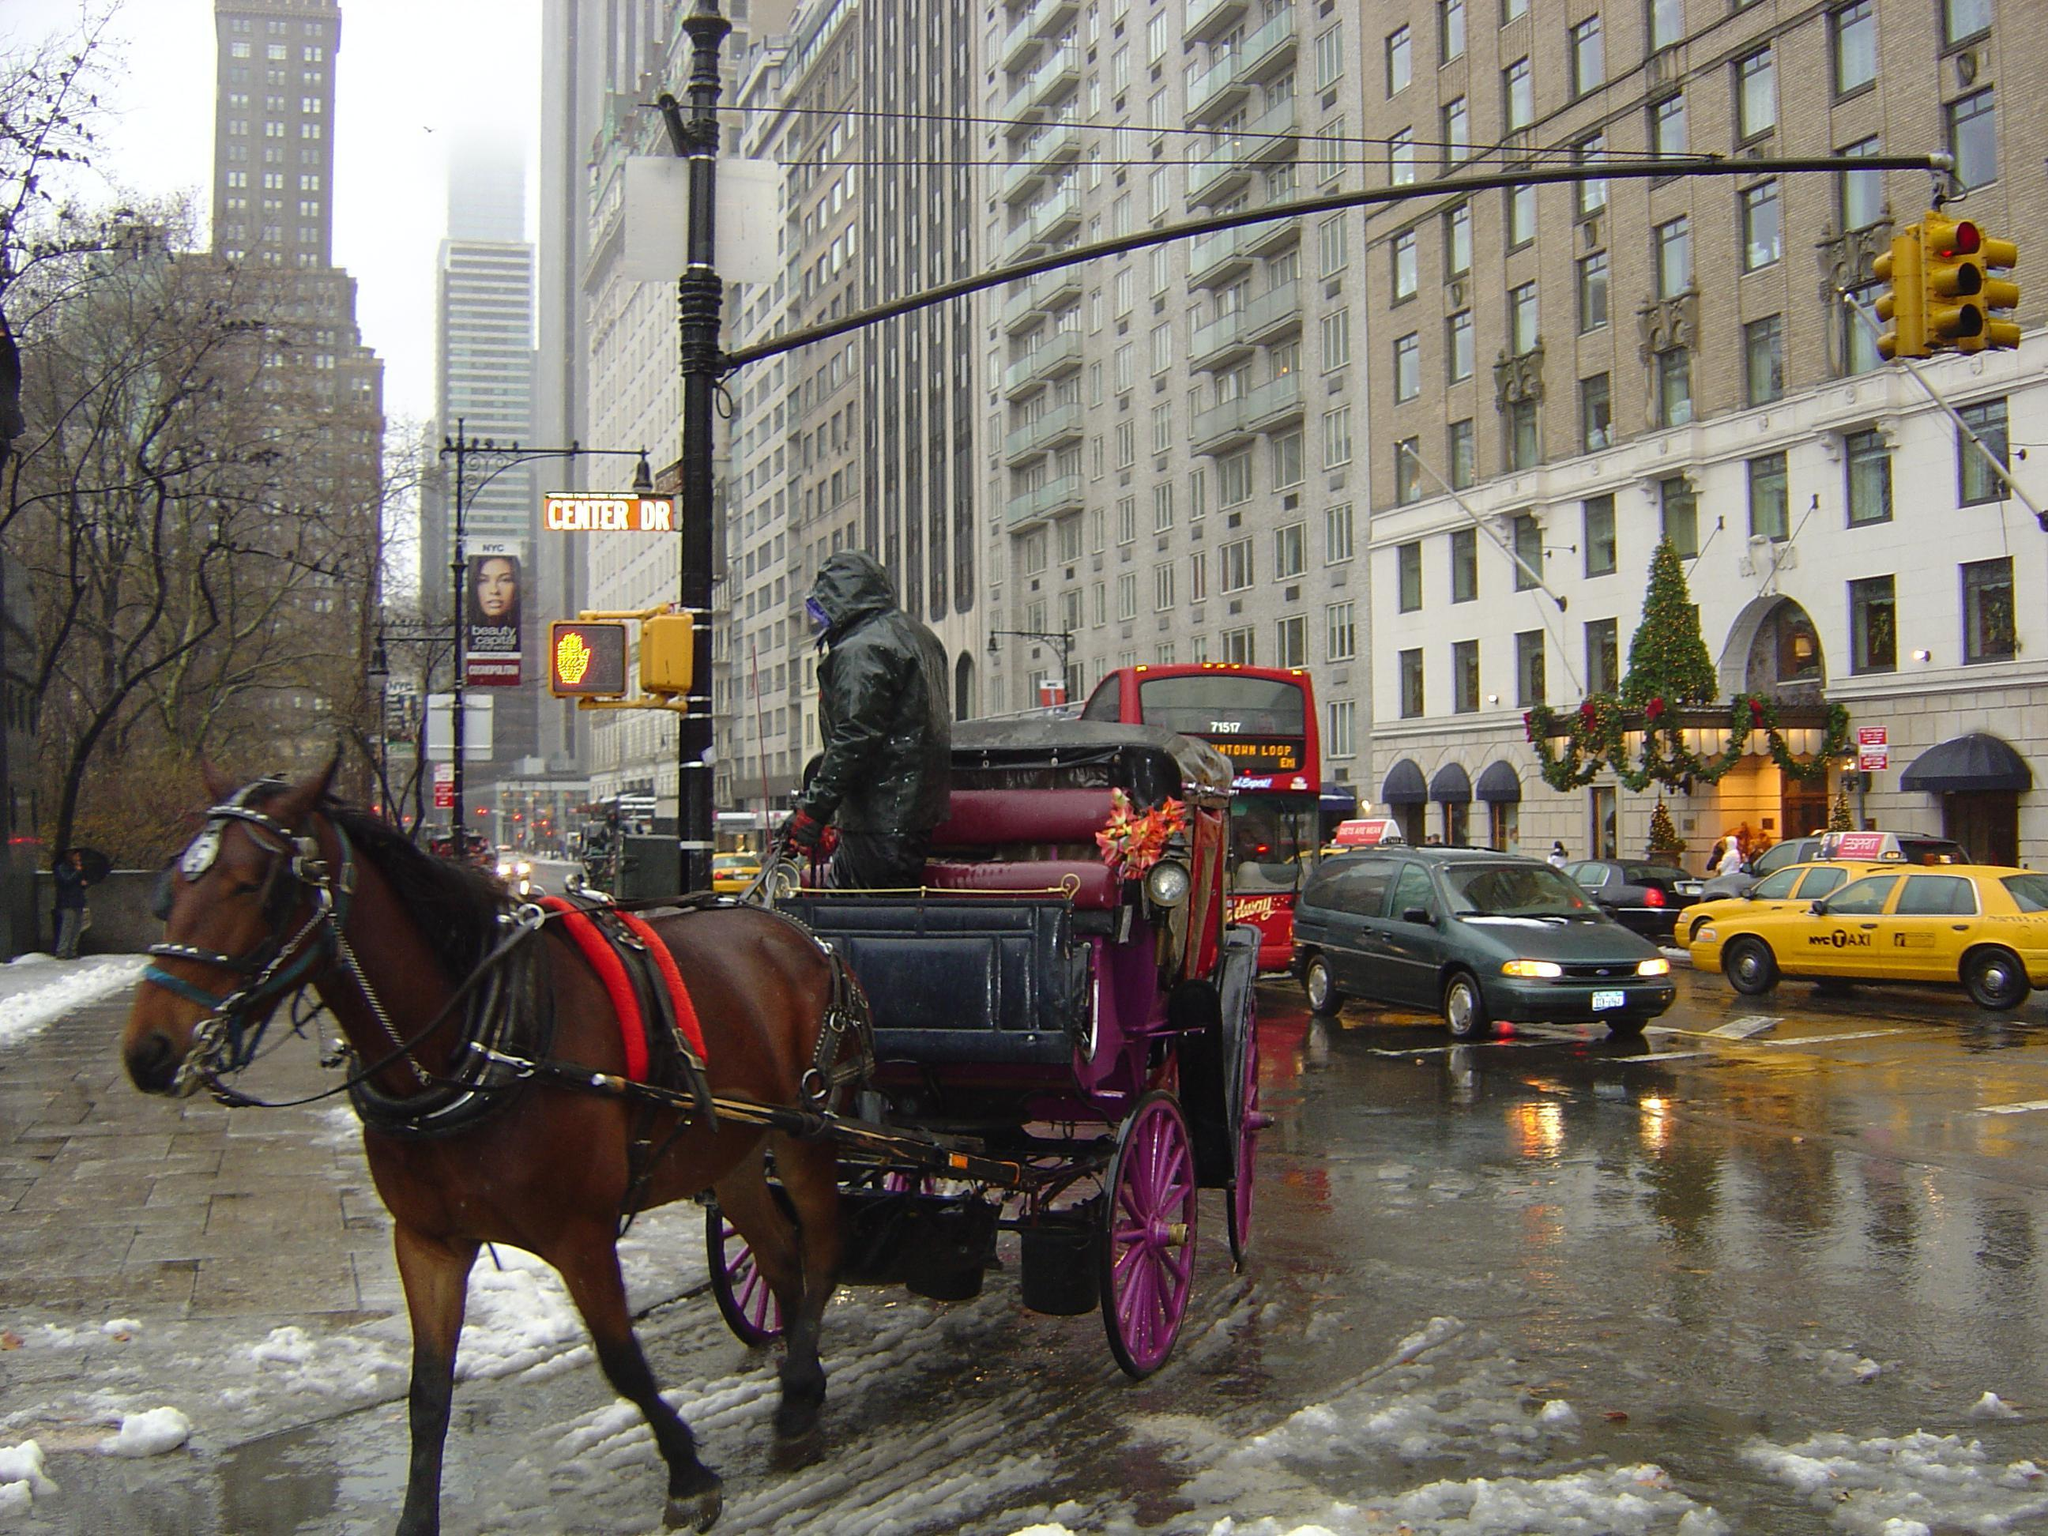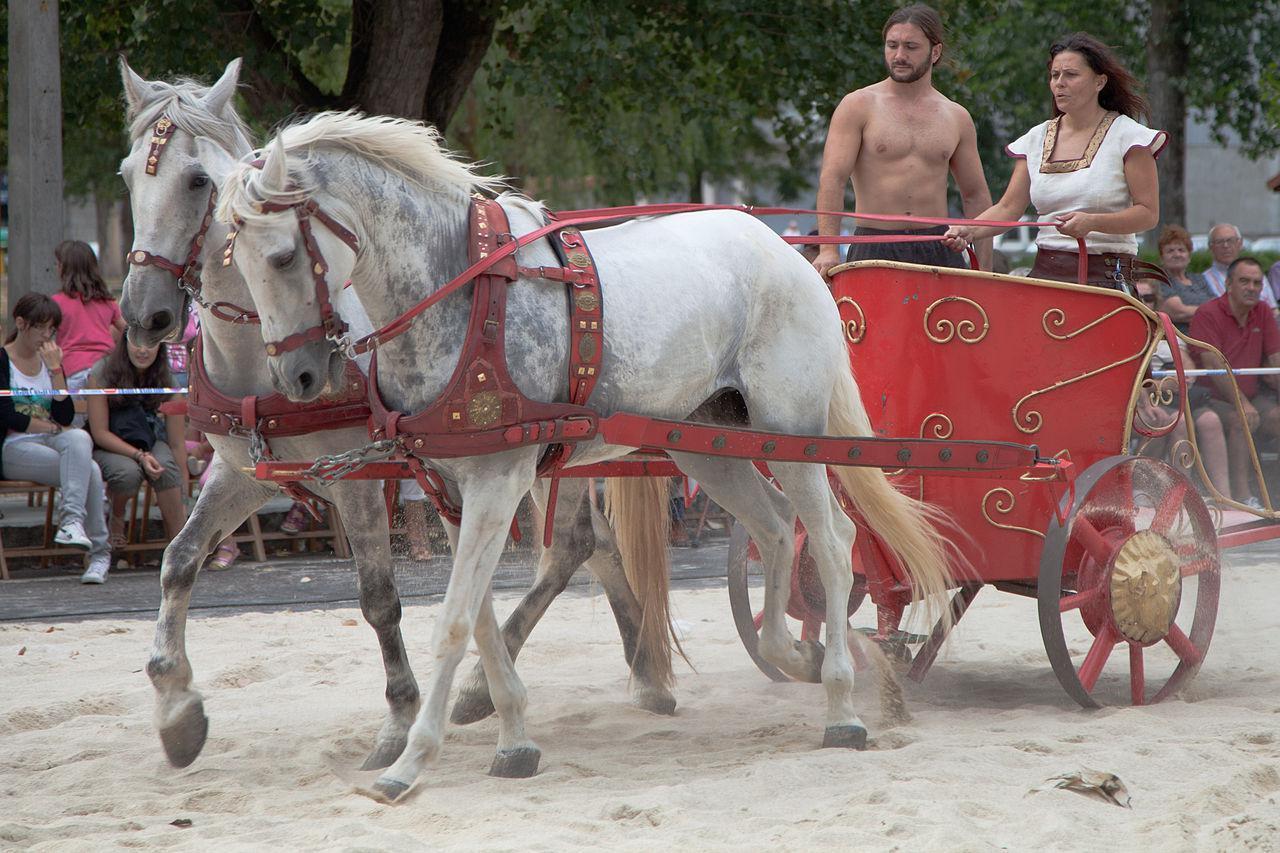The first image is the image on the left, the second image is the image on the right. Analyze the images presented: Is the assertion "All of the carts are being pulled by horses and none of the horses is being ridden by a person." valid? Answer yes or no. Yes. The first image is the image on the left, the second image is the image on the right. Considering the images on both sides, is "There is no more than one person in the left image." valid? Answer yes or no. Yes. 